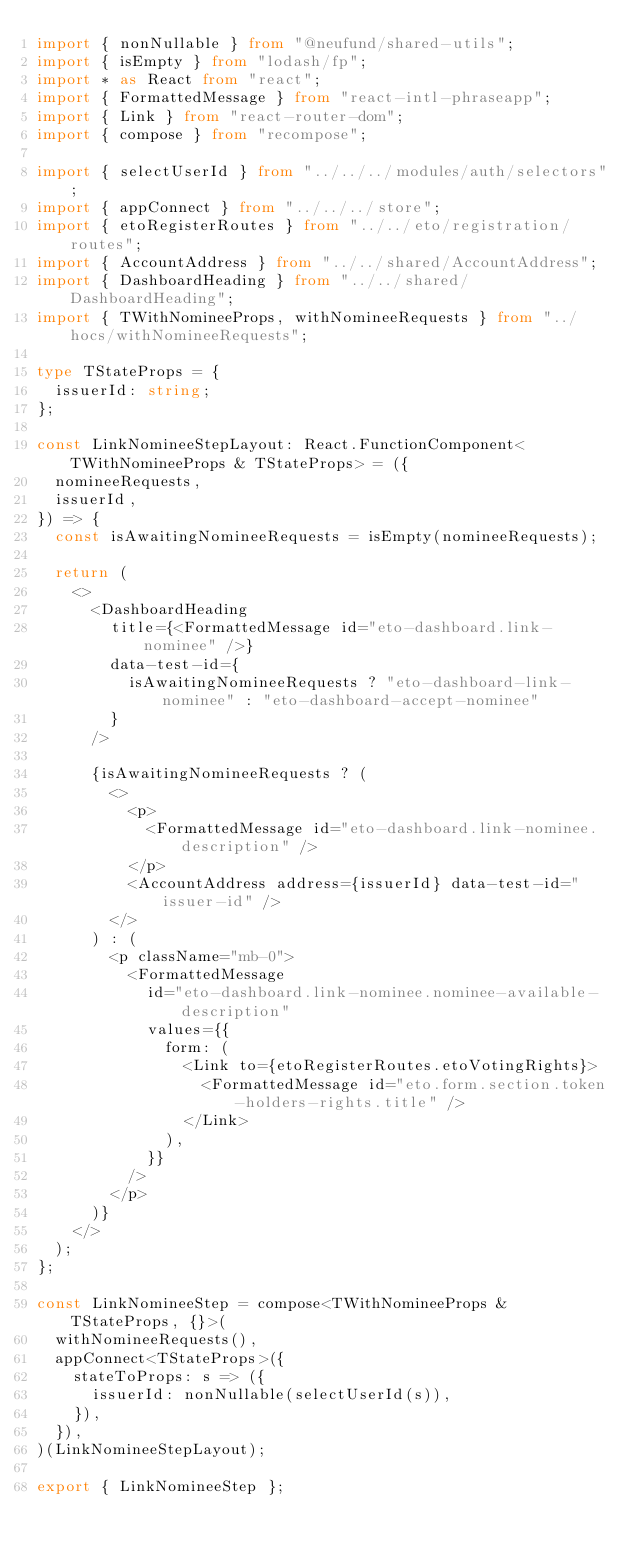<code> <loc_0><loc_0><loc_500><loc_500><_TypeScript_>import { nonNullable } from "@neufund/shared-utils";
import { isEmpty } from "lodash/fp";
import * as React from "react";
import { FormattedMessage } from "react-intl-phraseapp";
import { Link } from "react-router-dom";
import { compose } from "recompose";

import { selectUserId } from "../../../modules/auth/selectors";
import { appConnect } from "../../../store";
import { etoRegisterRoutes } from "../../eto/registration/routes";
import { AccountAddress } from "../../shared/AccountAddress";
import { DashboardHeading } from "../../shared/DashboardHeading";
import { TWithNomineeProps, withNomineeRequests } from "../hocs/withNomineeRequests";

type TStateProps = {
  issuerId: string;
};

const LinkNomineeStepLayout: React.FunctionComponent<TWithNomineeProps & TStateProps> = ({
  nomineeRequests,
  issuerId,
}) => {
  const isAwaitingNomineeRequests = isEmpty(nomineeRequests);

  return (
    <>
      <DashboardHeading
        title={<FormattedMessage id="eto-dashboard.link-nominee" />}
        data-test-id={
          isAwaitingNomineeRequests ? "eto-dashboard-link-nominee" : "eto-dashboard-accept-nominee"
        }
      />

      {isAwaitingNomineeRequests ? (
        <>
          <p>
            <FormattedMessage id="eto-dashboard.link-nominee.description" />
          </p>
          <AccountAddress address={issuerId} data-test-id="issuer-id" />
        </>
      ) : (
        <p className="mb-0">
          <FormattedMessage
            id="eto-dashboard.link-nominee.nominee-available-description"
            values={{
              form: (
                <Link to={etoRegisterRoutes.etoVotingRights}>
                  <FormattedMessage id="eto.form.section.token-holders-rights.title" />
                </Link>
              ),
            }}
          />
        </p>
      )}
    </>
  );
};

const LinkNomineeStep = compose<TWithNomineeProps & TStateProps, {}>(
  withNomineeRequests(),
  appConnect<TStateProps>({
    stateToProps: s => ({
      issuerId: nonNullable(selectUserId(s)),
    }),
  }),
)(LinkNomineeStepLayout);

export { LinkNomineeStep };
</code> 